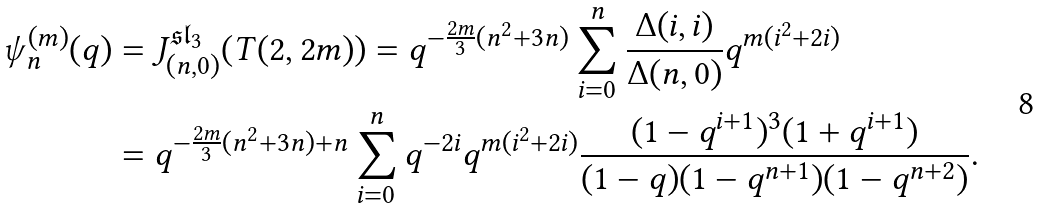<formula> <loc_0><loc_0><loc_500><loc_500>\psi _ { n } ^ { ( m ) } ( q ) & = J _ { ( n , 0 ) } ^ { \mathfrak { s l } _ { 3 } } ( T ( 2 , 2 m ) ) = q ^ { - \frac { 2 m } { 3 } ( n ^ { 2 } + 3 n ) } \sum _ { i = 0 } ^ { n } \frac { \Delta ( i , i ) } { \Delta ( n , 0 ) } q ^ { m ( i ^ { 2 } + 2 i ) } \\ & = q ^ { - \frac { 2 m } { 3 } ( n ^ { 2 } + 3 n ) + n } \sum _ { i = 0 } ^ { n } q ^ { - 2 i } q ^ { m ( i ^ { 2 } + 2 i ) } \frac { ( 1 - q ^ { i + 1 } ) ^ { 3 } ( 1 + q ^ { i + 1 } ) } { ( 1 - q ) ( 1 - q ^ { n + 1 } ) ( 1 - q ^ { n + 2 } ) } .</formula> 